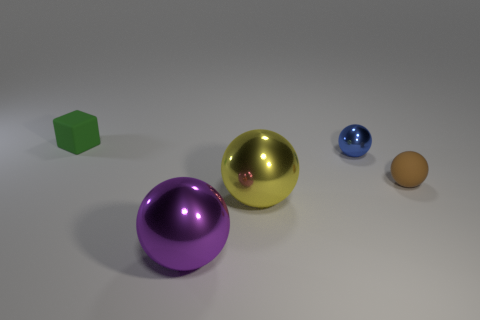Add 1 big cyan cylinders. How many objects exist? 6 Subtract all balls. How many objects are left? 1 Subtract 0 purple cylinders. How many objects are left? 5 Subtract all spheres. Subtract all tiny gray shiny blocks. How many objects are left? 1 Add 1 tiny matte cubes. How many tiny matte cubes are left? 2 Add 2 blue rubber objects. How many blue rubber objects exist? 2 